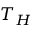Convert formula to latex. <formula><loc_0><loc_0><loc_500><loc_500>T _ { H }</formula> 